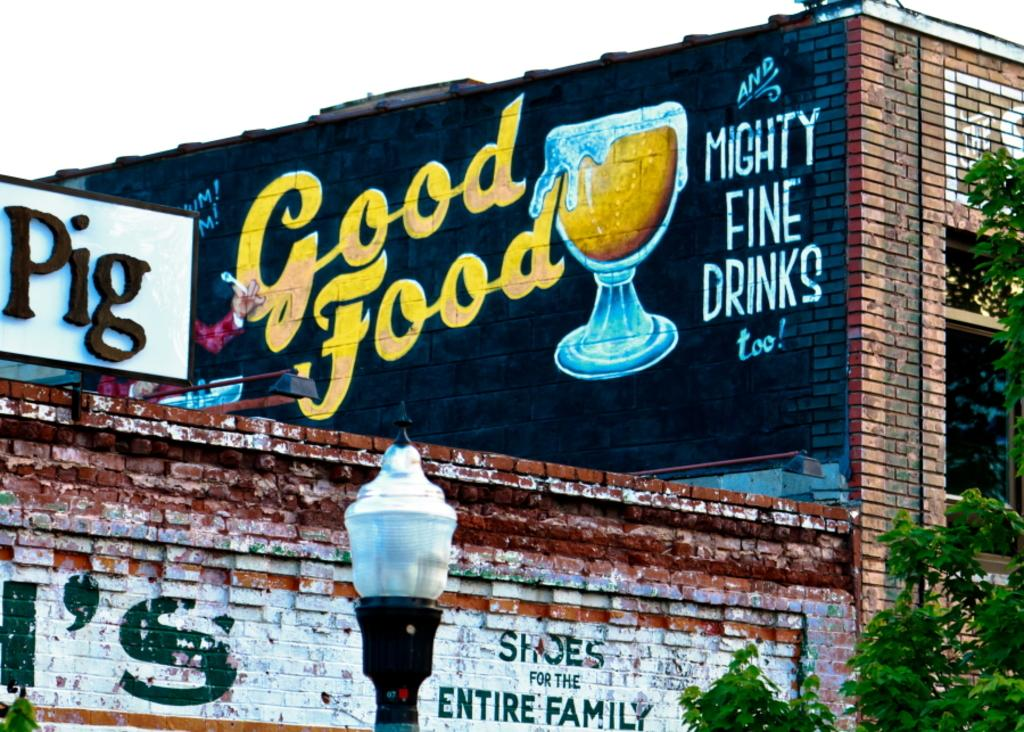What type of building is visible in the image? There is a building made of bricks in the image. What other structures can be seen in the image? There is a light pole in the image. What type of vegetation is present in the image? There are trees in the image. What type of signage is visible in the image? There is a poster in the image. What part of the natural environment is visible in the image? The sky is visible in the image. What type of artwork is present in the image? There is a painting on the wall in the image. What type of battle is taking place in the image? There is no battle present in the image; it features a building, light pole, trees, poster, sky, and painting on the wall. 